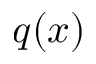<formula> <loc_0><loc_0><loc_500><loc_500>q ( x )</formula> 